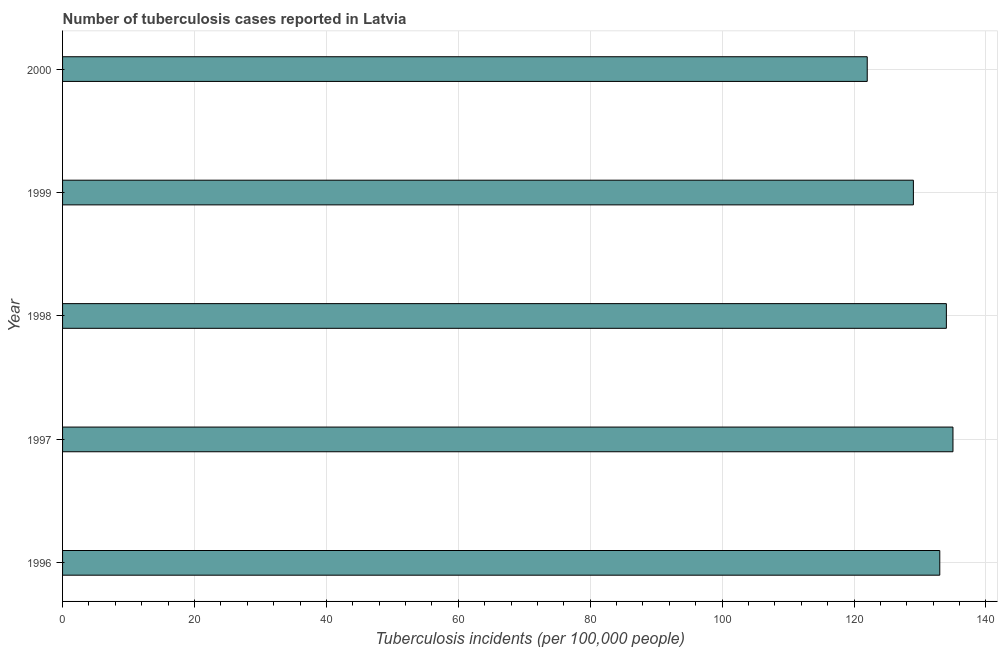Does the graph contain any zero values?
Your answer should be compact. No. What is the title of the graph?
Give a very brief answer. Number of tuberculosis cases reported in Latvia. What is the label or title of the X-axis?
Your response must be concise. Tuberculosis incidents (per 100,0 people). What is the number of tuberculosis incidents in 1998?
Keep it short and to the point. 134. Across all years, what is the maximum number of tuberculosis incidents?
Ensure brevity in your answer.  135. Across all years, what is the minimum number of tuberculosis incidents?
Provide a short and direct response. 122. In which year was the number of tuberculosis incidents minimum?
Your answer should be very brief. 2000. What is the sum of the number of tuberculosis incidents?
Ensure brevity in your answer.  653. What is the average number of tuberculosis incidents per year?
Offer a very short reply. 130. What is the median number of tuberculosis incidents?
Offer a very short reply. 133. What is the ratio of the number of tuberculosis incidents in 1996 to that in 2000?
Your answer should be compact. 1.09. Is the number of tuberculosis incidents in 1996 less than that in 1997?
Provide a short and direct response. Yes. How many years are there in the graph?
Your response must be concise. 5. What is the difference between two consecutive major ticks on the X-axis?
Your answer should be compact. 20. What is the Tuberculosis incidents (per 100,000 people) in 1996?
Offer a very short reply. 133. What is the Tuberculosis incidents (per 100,000 people) of 1997?
Keep it short and to the point. 135. What is the Tuberculosis incidents (per 100,000 people) in 1998?
Provide a succinct answer. 134. What is the Tuberculosis incidents (per 100,000 people) in 1999?
Your answer should be very brief. 129. What is the Tuberculosis incidents (per 100,000 people) of 2000?
Your answer should be very brief. 122. What is the difference between the Tuberculosis incidents (per 100,000 people) in 1996 and 1998?
Your answer should be very brief. -1. What is the difference between the Tuberculosis incidents (per 100,000 people) in 1997 and 1998?
Offer a very short reply. 1. What is the difference between the Tuberculosis incidents (per 100,000 people) in 1997 and 2000?
Your answer should be very brief. 13. What is the difference between the Tuberculosis incidents (per 100,000 people) in 1998 and 1999?
Your answer should be very brief. 5. What is the ratio of the Tuberculosis incidents (per 100,000 people) in 1996 to that in 1999?
Your response must be concise. 1.03. What is the ratio of the Tuberculosis incidents (per 100,000 people) in 1996 to that in 2000?
Keep it short and to the point. 1.09. What is the ratio of the Tuberculosis incidents (per 100,000 people) in 1997 to that in 1998?
Your response must be concise. 1.01. What is the ratio of the Tuberculosis incidents (per 100,000 people) in 1997 to that in 1999?
Offer a very short reply. 1.05. What is the ratio of the Tuberculosis incidents (per 100,000 people) in 1997 to that in 2000?
Your answer should be compact. 1.11. What is the ratio of the Tuberculosis incidents (per 100,000 people) in 1998 to that in 1999?
Ensure brevity in your answer.  1.04. What is the ratio of the Tuberculosis incidents (per 100,000 people) in 1998 to that in 2000?
Your answer should be compact. 1.1. What is the ratio of the Tuberculosis incidents (per 100,000 people) in 1999 to that in 2000?
Keep it short and to the point. 1.06. 